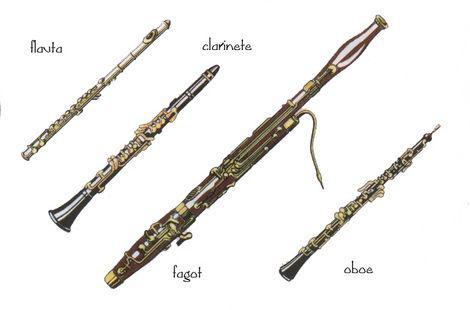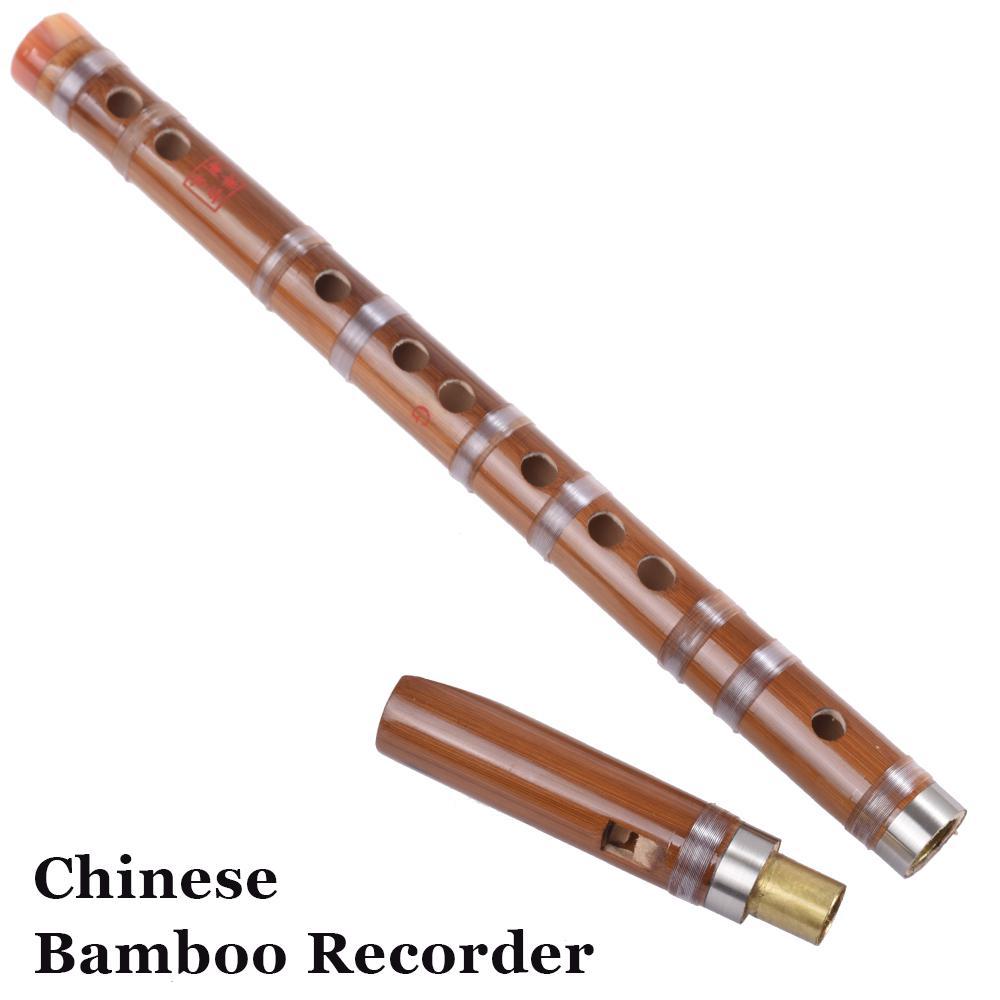The first image is the image on the left, the second image is the image on the right. Considering the images on both sides, is "There are exactly two assembled flutes." valid? Answer yes or no. No. The first image is the image on the left, the second image is the image on the right. Assess this claim about the two images: "There are at least two metal wind instruments.". Correct or not? Answer yes or no. Yes. 